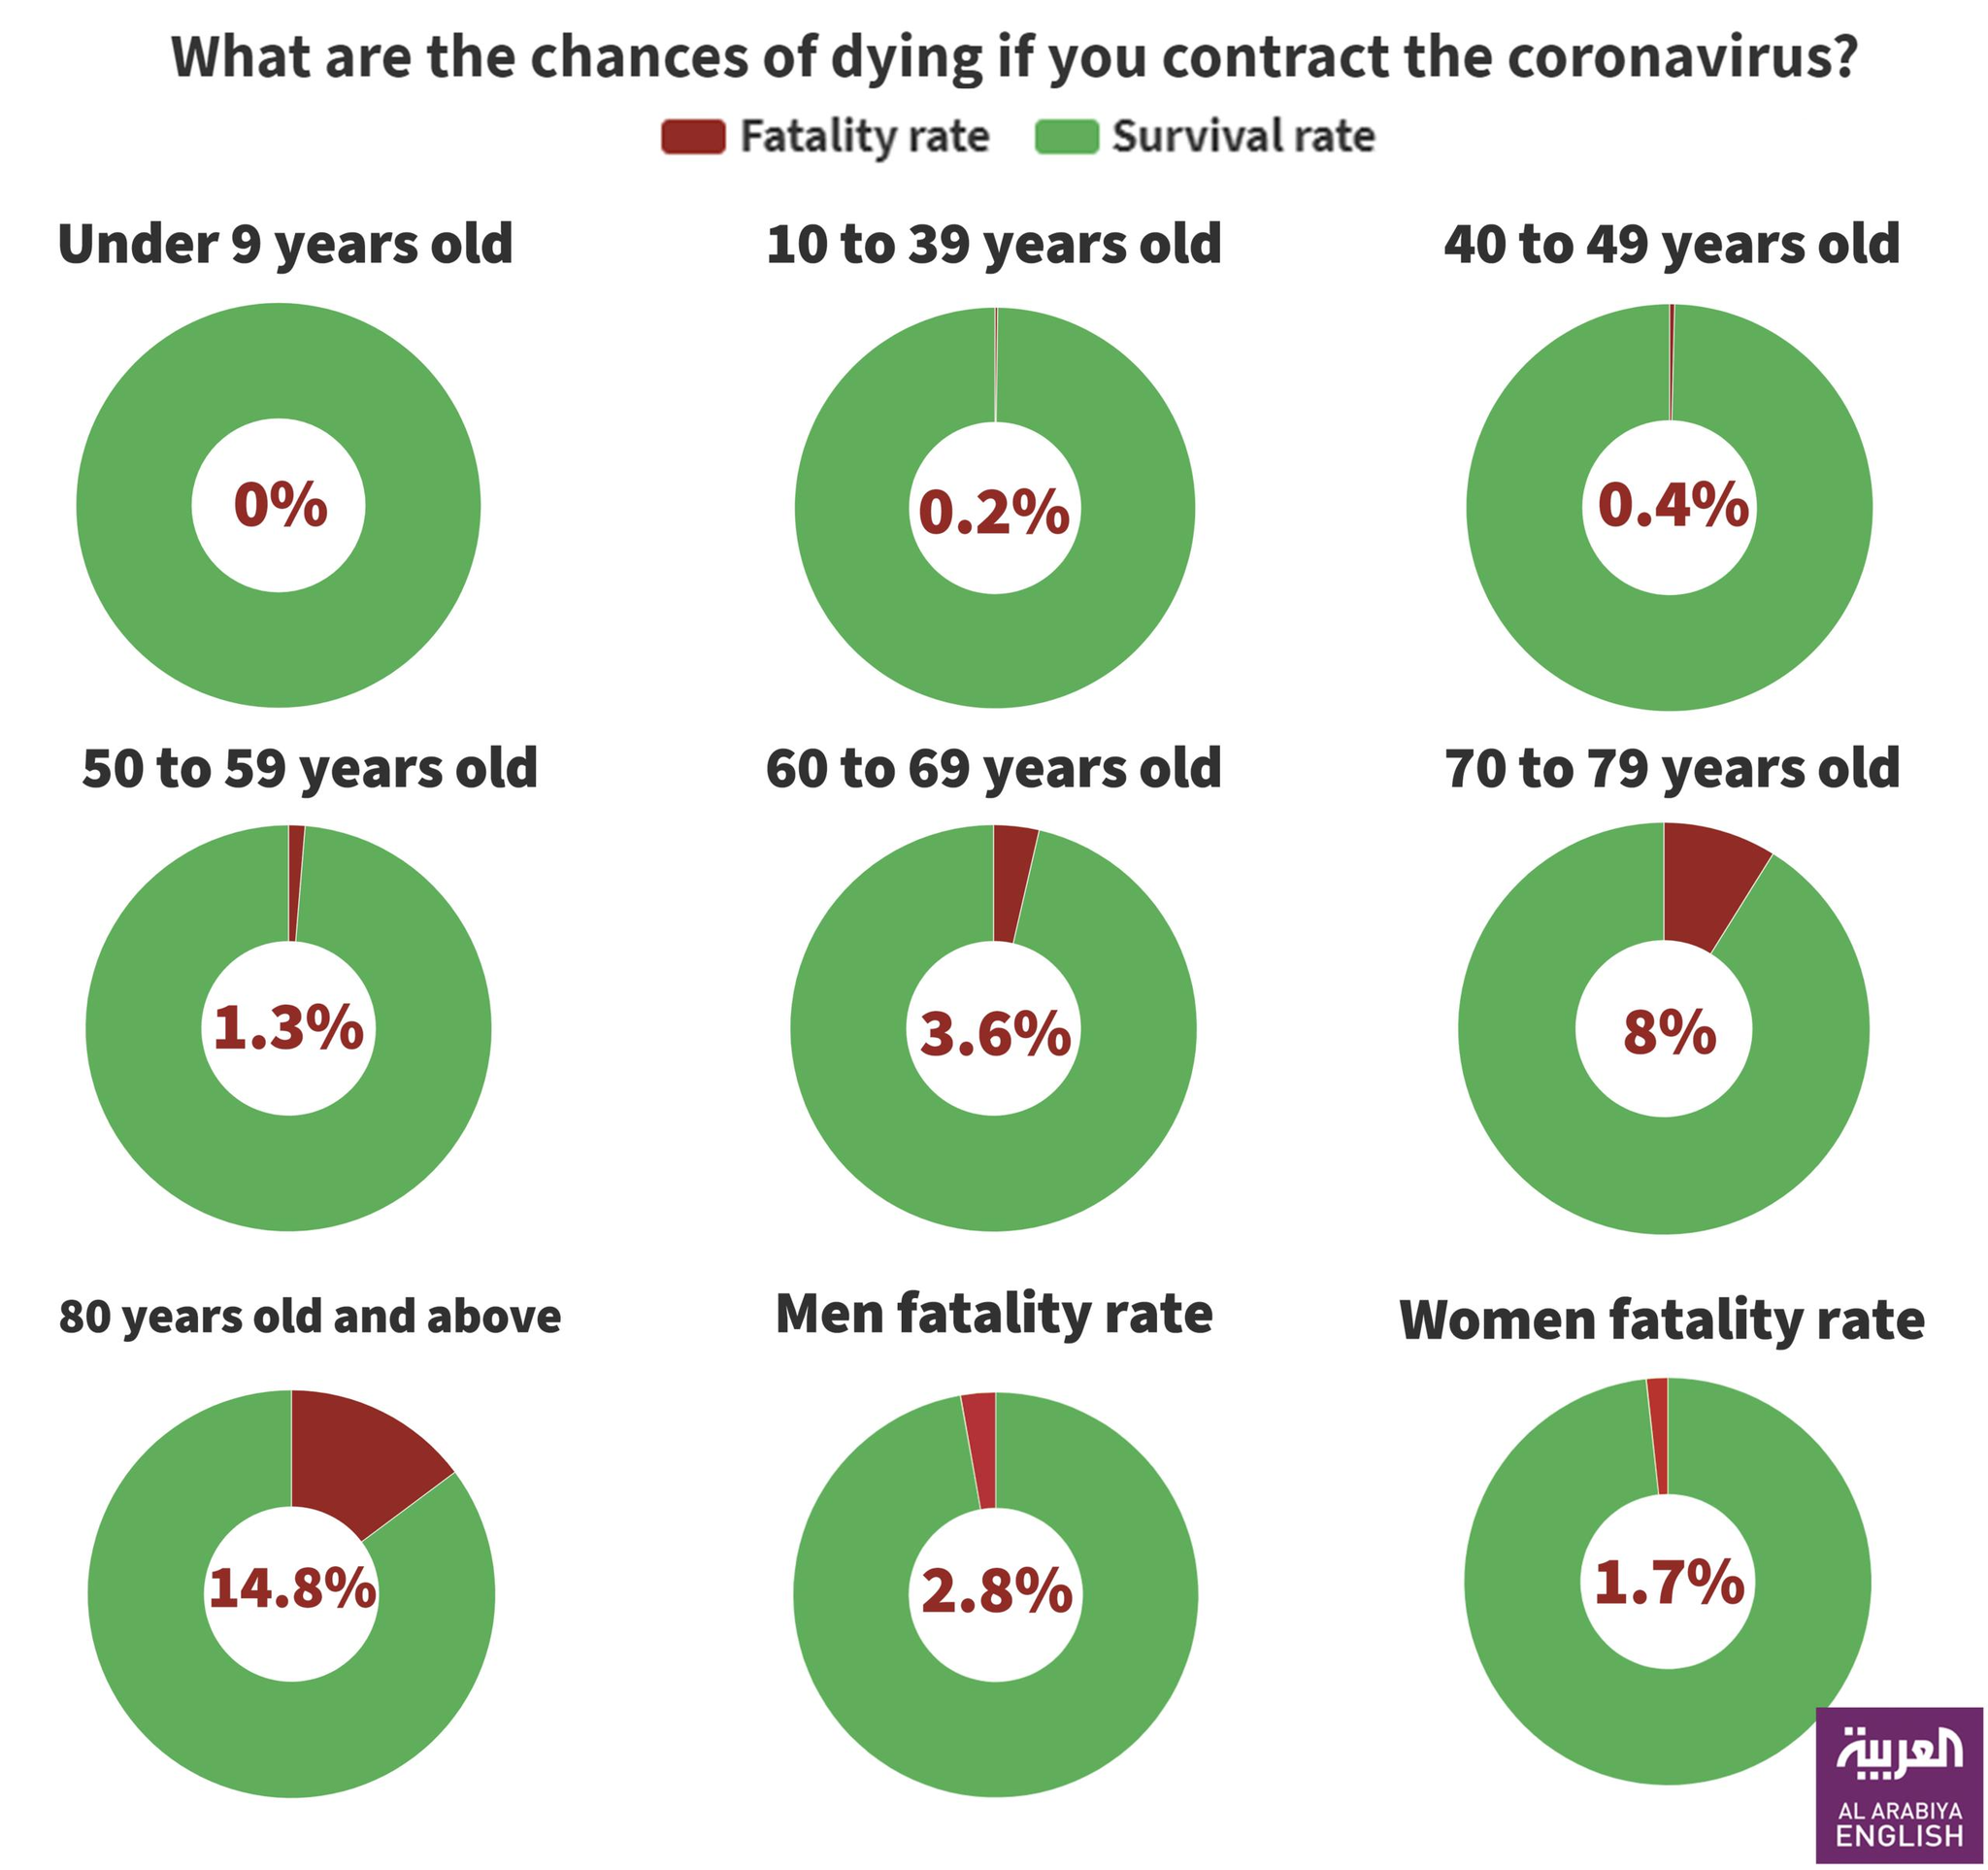Highlight a few significant elements in this photo. The second-highest risk of COVID-19 among people is found in individuals aged 70 to 79 years old. The color code assigned to the survival rate is green. The elderly population, specifically those aged 80 years and above, are at high risk of contracting COVID-19 due to their weaker immune systems and higher likelihood of having underlying medical conditions. The fatality rate of males is greater than that of females, with a difference of 1.1. According to the given information, the fatality rate of males is 2.8%. 